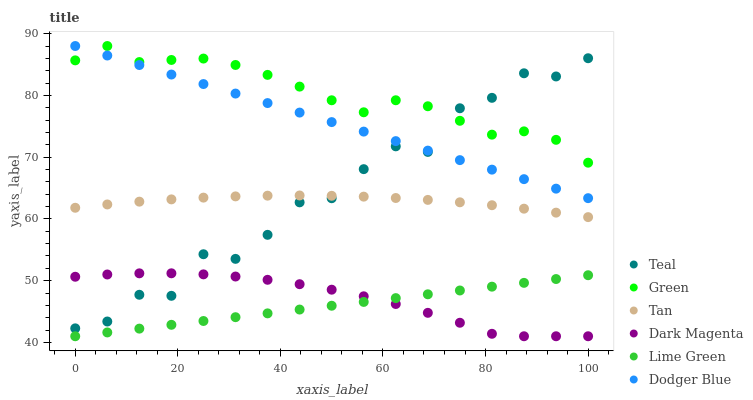Does Lime Green have the minimum area under the curve?
Answer yes or no. Yes. Does Green have the maximum area under the curve?
Answer yes or no. Yes. Does Teal have the minimum area under the curve?
Answer yes or no. No. Does Teal have the maximum area under the curve?
Answer yes or no. No. Is Lime Green the smoothest?
Answer yes or no. Yes. Is Teal the roughest?
Answer yes or no. Yes. Is Green the smoothest?
Answer yes or no. No. Is Green the roughest?
Answer yes or no. No. Does Dark Magenta have the lowest value?
Answer yes or no. Yes. Does Teal have the lowest value?
Answer yes or no. No. Does Dodger Blue have the highest value?
Answer yes or no. Yes. Does Teal have the highest value?
Answer yes or no. No. Is Dark Magenta less than Tan?
Answer yes or no. Yes. Is Teal greater than Lime Green?
Answer yes or no. Yes. Does Teal intersect Dodger Blue?
Answer yes or no. Yes. Is Teal less than Dodger Blue?
Answer yes or no. No. Is Teal greater than Dodger Blue?
Answer yes or no. No. Does Dark Magenta intersect Tan?
Answer yes or no. No. 